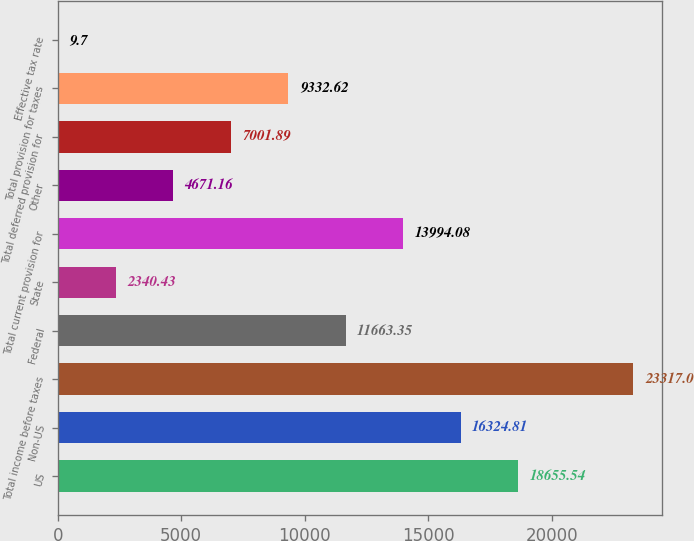<chart> <loc_0><loc_0><loc_500><loc_500><bar_chart><fcel>US<fcel>Non-US<fcel>Total income before taxes<fcel>Federal<fcel>State<fcel>Total current provision for<fcel>Other<fcel>Total deferred provision for<fcel>Total provision for taxes<fcel>Effective tax rate<nl><fcel>18655.5<fcel>16324.8<fcel>23317<fcel>11663.4<fcel>2340.43<fcel>13994.1<fcel>4671.16<fcel>7001.89<fcel>9332.62<fcel>9.7<nl></chart> 